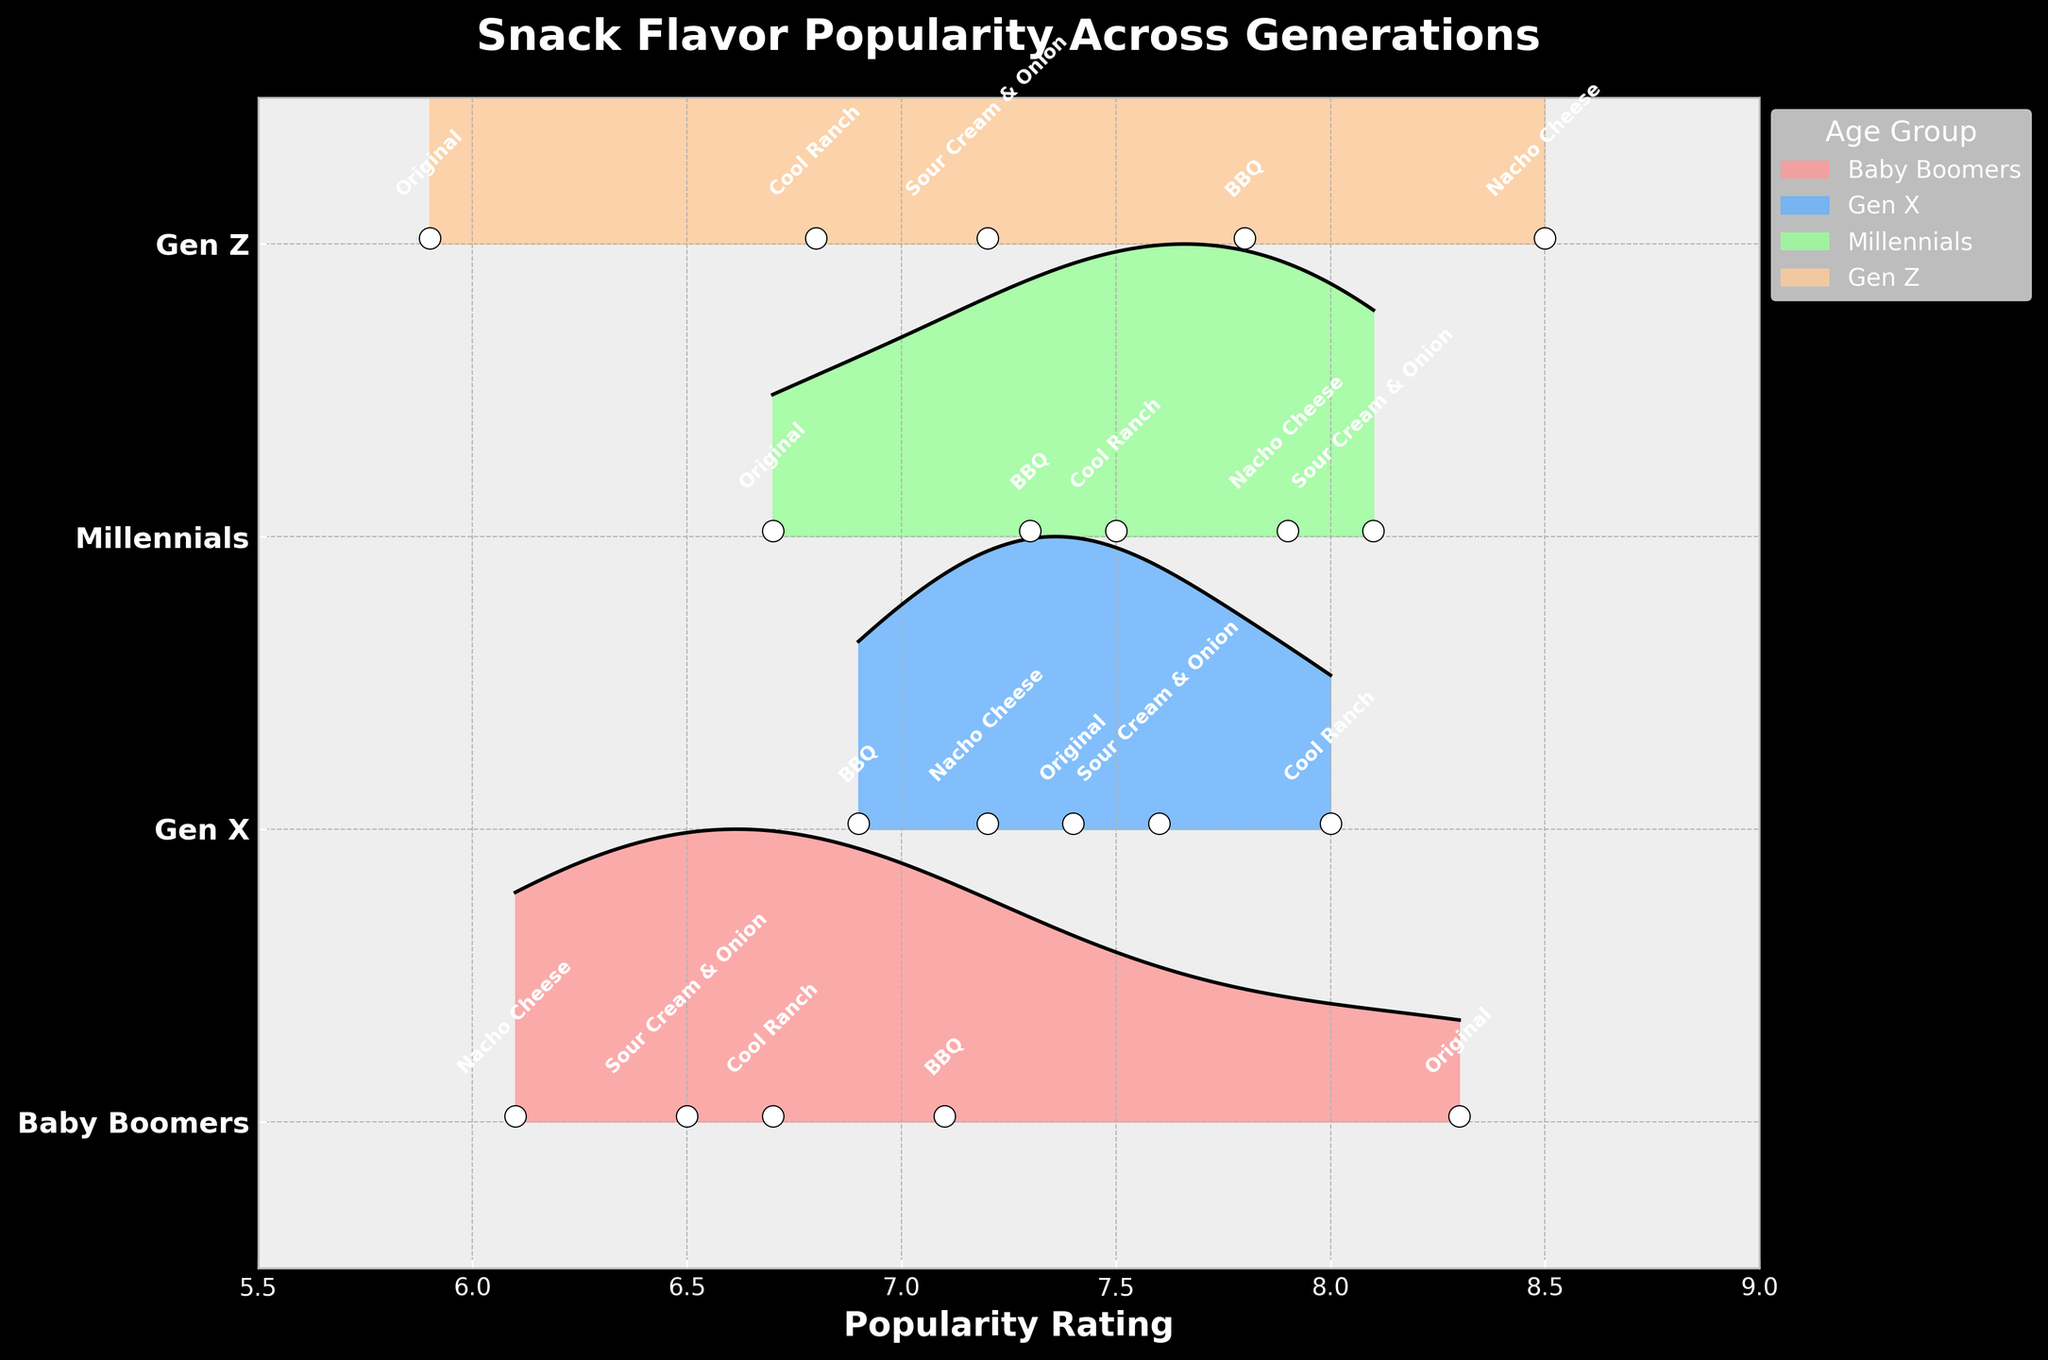What is the title of the figure? The title of the figure is displayed at the top and usually summarizes the content or main takeaway of the figure. The title in this context should provide information on the subject of popularity ratings across age groups.
Answer: Snack Flavor Popularity Across Generations Which age group has the highest popularity rating for Sour Cream & Onion? By comparing the popularity values for Sour Cream & Onion across all age groups on the y-axis, the group with the highest rating is visible. Gen X has a rating of 7.6, whereas others have lower ratings.
Answer: Millennials Which snack flavor has the highest popularity rating among Gen Z? Among the data points labeled for Gen Z, the snack flavor with the highest rating needs to be identified. Nacho Cheese has an 8.5 rating, which is higher than the others.
Answer: Nacho Cheese How does the popularity of Original flavor differ between Baby Boomers and Gen Z? To find the difference, subtract the popularity rating of Original flavor in Gen Z from that in Baby Boomers. Baby Boomers have a rating of 8.3, and Gen Z has a rating of 5.9. The calculation is 8.3 - 5.9.
Answer: 2.4 Which age group has the widest spread of popularity ratings? The spread of ratings for each age group can be gauged by noting the range between the minimum and maximum popularity values. By observing the maximum and minimum values for each age group, one can determine the widest spread. Gen Z ranges from 5.9 to 8.5, giving a spread of 2.6. The others have smaller ranges.
Answer: Gen Z Which flavor is least popular among Baby Boomers? By checking the labeled data points for Baby Boomers, the flavor with the lowest popularity rating should be identified. Nacho Cheese has the lowest rating of 6.1 among the options.
Answer: Nacho Cheese How do the overall rating trends for Sour Cream & Onion differ across age groups? Examining each age group's rating for Sour Cream & Onion shows the trend. The ratings are: Gen Z 7.2, Millennials 8.1, Gen X 7.6, Baby Boomers 6.5. Millennials rate it highest, while Baby Boomers rate it lowest.
Answer: Millennials highest, Baby Boomers lowest 